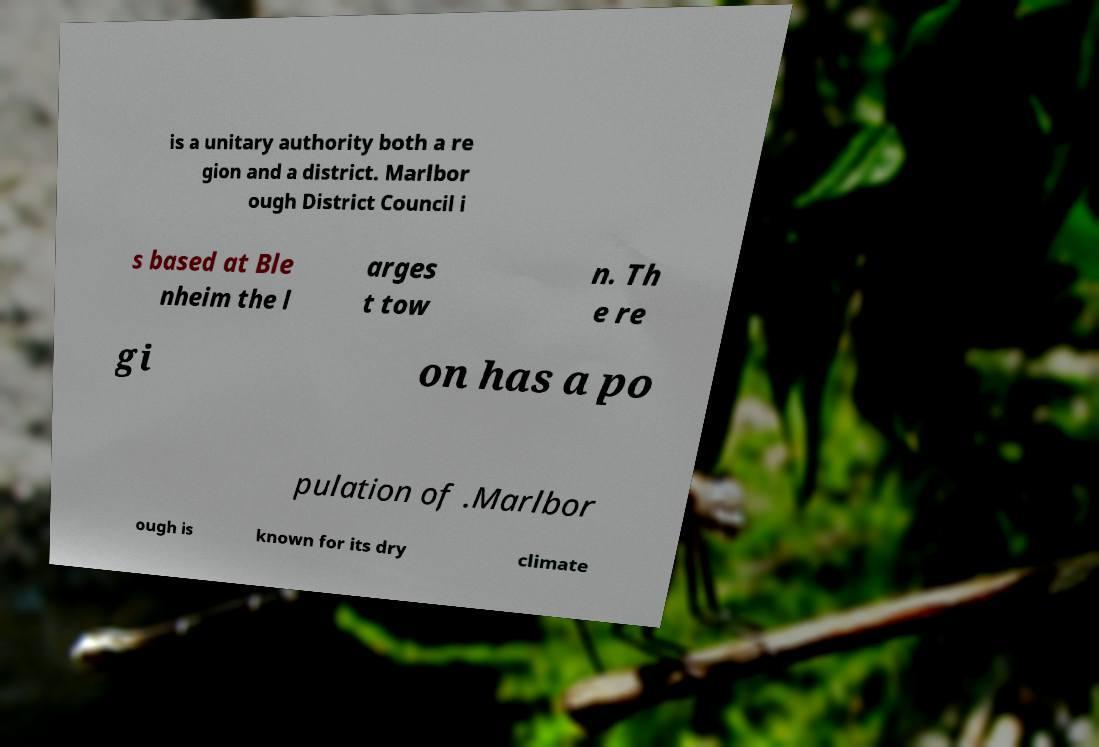For documentation purposes, I need the text within this image transcribed. Could you provide that? is a unitary authority both a re gion and a district. Marlbor ough District Council i s based at Ble nheim the l arges t tow n. Th e re gi on has a po pulation of .Marlbor ough is known for its dry climate 